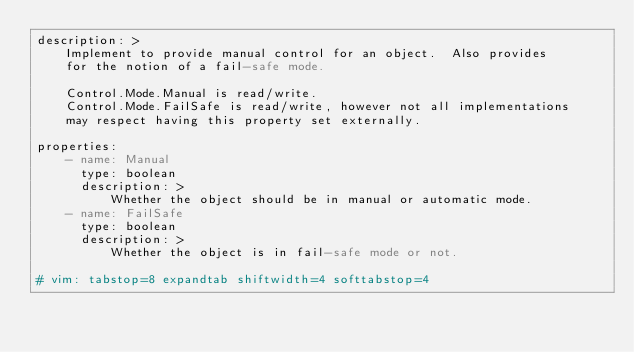Convert code to text. <code><loc_0><loc_0><loc_500><loc_500><_YAML_>description: >
    Implement to provide manual control for an object.  Also provides
    for the notion of a fail-safe mode.

    Control.Mode.Manual is read/write.
    Control.Mode.FailSafe is read/write, however not all implementations
    may respect having this property set externally.

properties:
    - name: Manual
      type: boolean
      description: >
          Whether the object should be in manual or automatic mode.
    - name: FailSafe
      type: boolean
      description: >
          Whether the object is in fail-safe mode or not.

# vim: tabstop=8 expandtab shiftwidth=4 softtabstop=4
</code> 